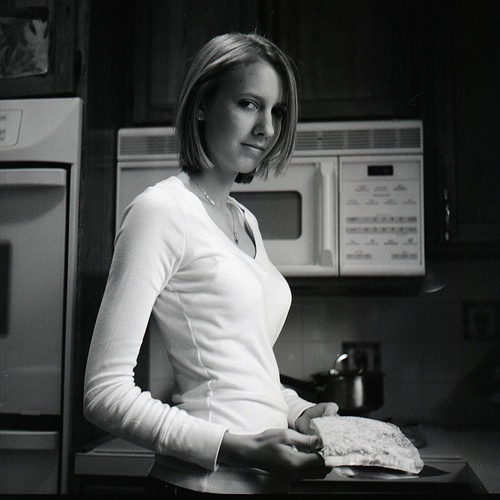Describe the objects in this image and their specific colors. I can see people in black, lightgray, darkgray, and gray tones, refrigerator in black and gray tones, microwave in black, gray, and darkgray tones, oven in black and gray tones, and pizza in black, lightgray, darkgray, and gray tones in this image. 